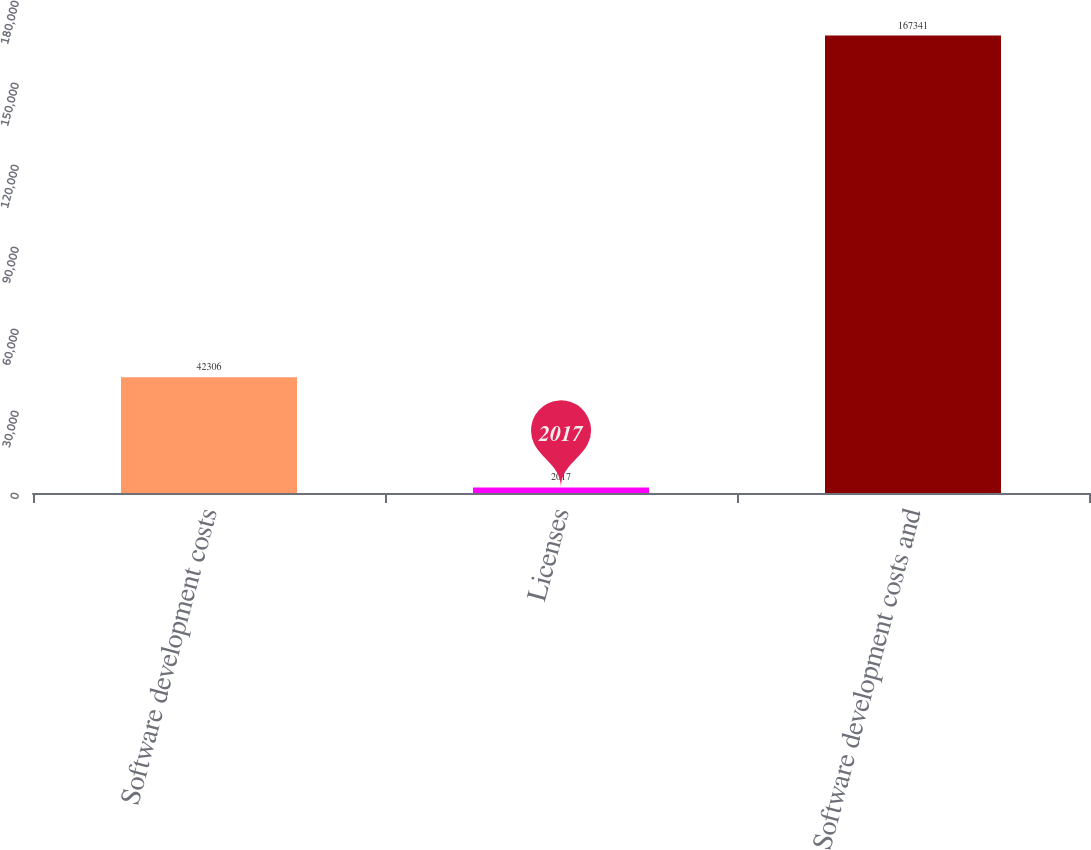Convert chart to OTSL. <chart><loc_0><loc_0><loc_500><loc_500><bar_chart><fcel>Software development costs<fcel>Licenses<fcel>Software development costs and<nl><fcel>42306<fcel>2017<fcel>167341<nl></chart> 